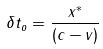<formula> <loc_0><loc_0><loc_500><loc_500>\delta t _ { o } = \frac { x ^ { * } } { ( c - v ) }</formula> 